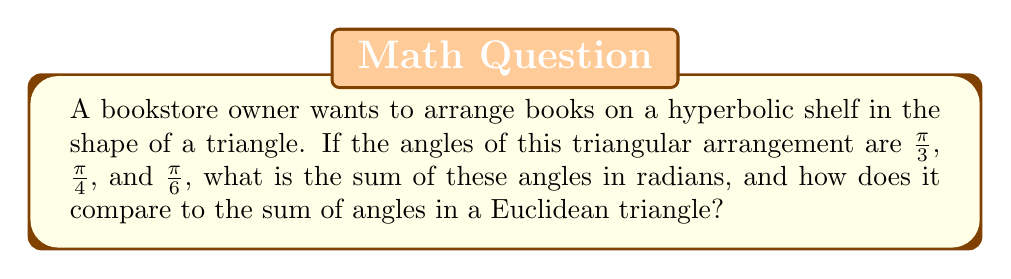Show me your answer to this math problem. Let's approach this step-by-step:

1) In hyperbolic geometry, the sum of angles in a triangle is always less than $\pi$ radians (or 180°).

2) To find the sum of the given angles, we add them:

   $$S = \frac{\pi}{3} + \frac{\pi}{4} + \frac{\pi}{6}$$

3) To simplify this, let's find a common denominator:
   
   $$S = \frac{4\pi}{12} + \frac{3\pi}{12} + \frac{2\pi}{12}$$

4) Now we can add the fractions:

   $$S = \frac{9\pi}{12} = \frac{3\pi}{4}$$

5) We can convert this to a decimal:

   $$\frac{3\pi}{4} \approx 2.3562 \text{ radians}$$

6) In comparison, the sum of angles in a Euclidean triangle is always exactly $\pi$ radians or 180°.

7) The difference between the Euclidean sum and our hyperbolic sum is:

   $$\pi - \frac{3\pi}{4} = \frac{\pi}{4} \approx 0.7854 \text{ radians}$$

This difference is known as the defect of the hyperbolic triangle.
Answer: $\frac{3\pi}{4}$ radians, which is less than the Euclidean sum of $\pi$ radians. 